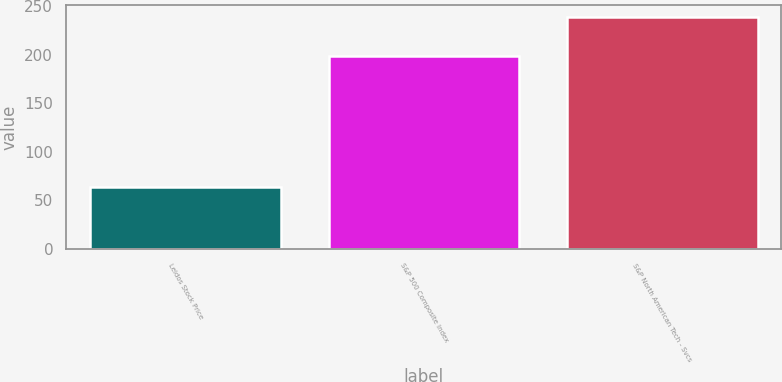<chart> <loc_0><loc_0><loc_500><loc_500><bar_chart><fcel>Leidos Stock Price<fcel>S&P 500 Composite Index<fcel>S&P North American Tech - Svcs<nl><fcel>64<fcel>198<fcel>239<nl></chart> 